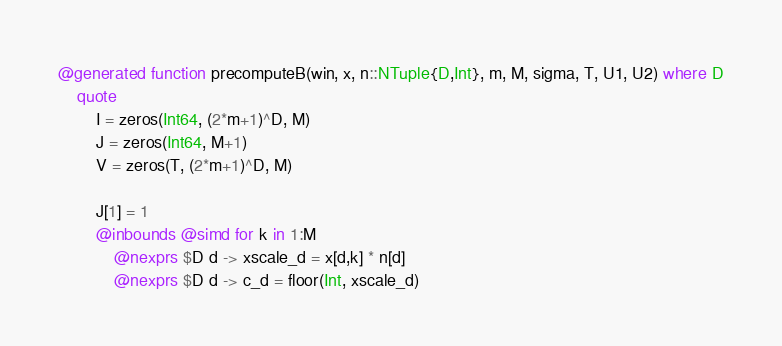<code> <loc_0><loc_0><loc_500><loc_500><_Julia_>
@generated function precomputeB(win, x, n::NTuple{D,Int}, m, M, sigma, T, U1, U2) where D
    quote
        I = zeros(Int64, (2*m+1)^D, M)
        J = zeros(Int64, M+1)
        V = zeros(T, (2*m+1)^D, M)

        J[1] = 1
        @inbounds @simd for k in 1:M
            @nexprs $D d -> xscale_d = x[d,k] * n[d]
            @nexprs $D d -> c_d = floor(Int, xscale_d)
</code> 